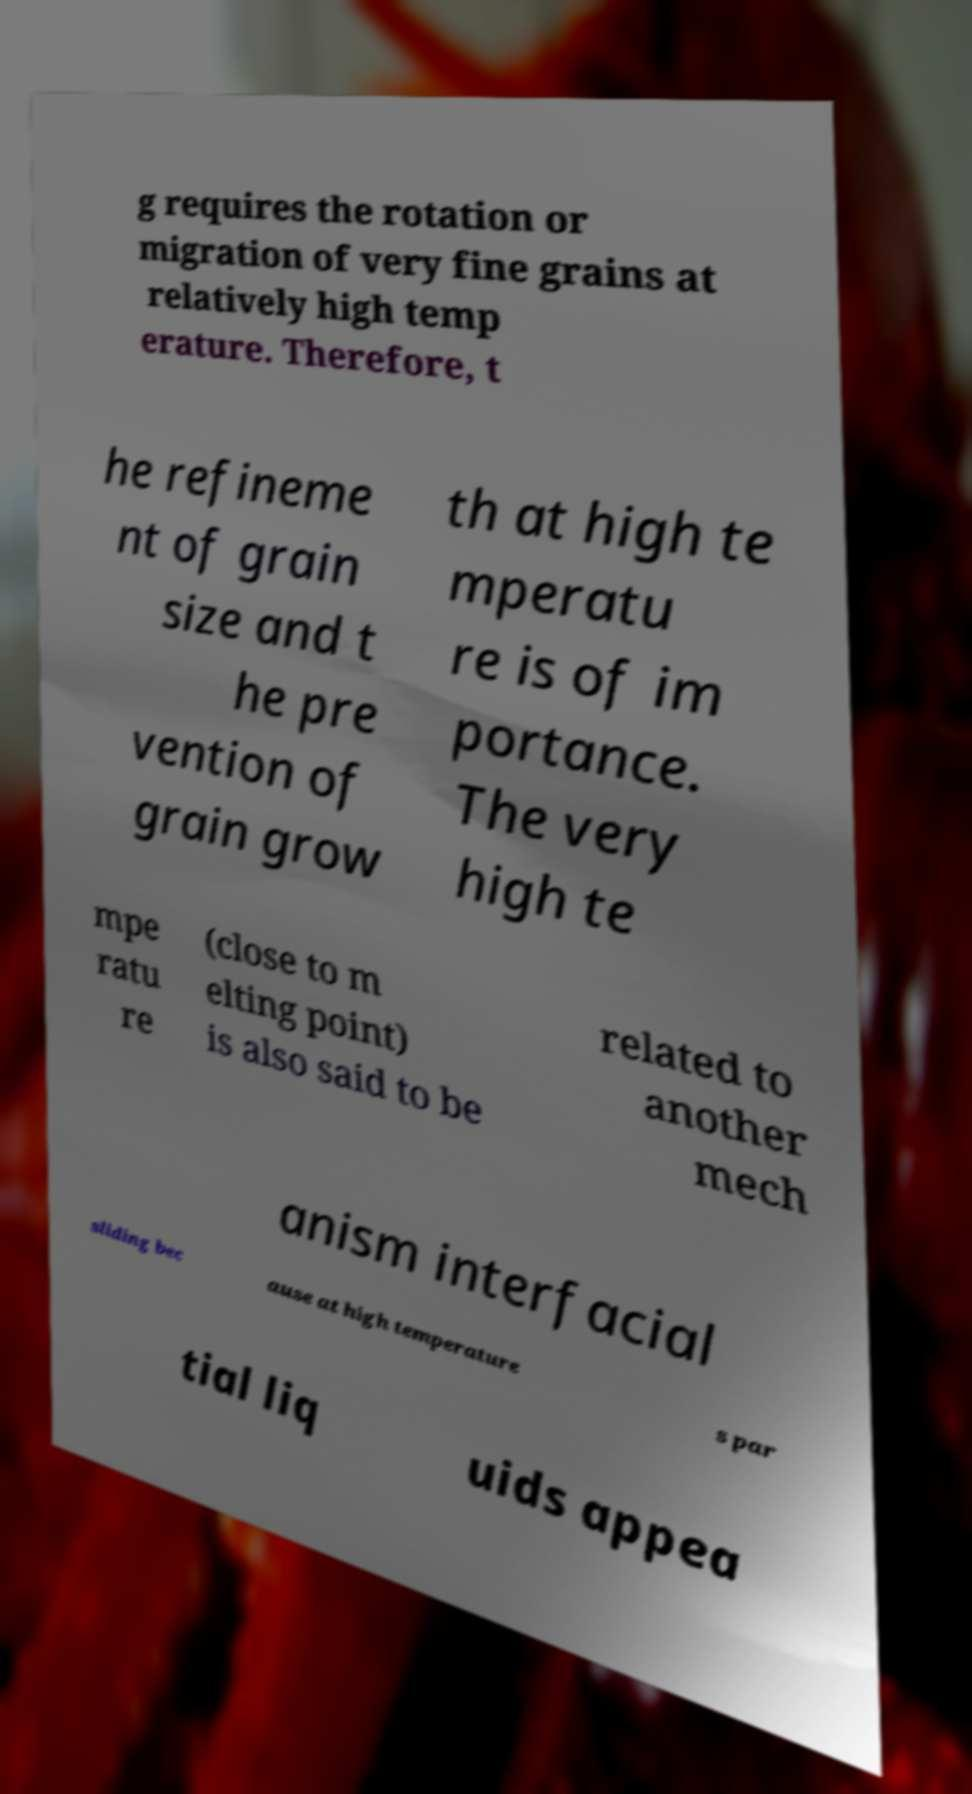Can you accurately transcribe the text from the provided image for me? g requires the rotation or migration of very fine grains at relatively high temp erature. Therefore, t he refineme nt of grain size and t he pre vention of grain grow th at high te mperatu re is of im portance. The very high te mpe ratu re (close to m elting point) is also said to be related to another mech anism interfacial sliding bec ause at high temperature s par tial liq uids appea 